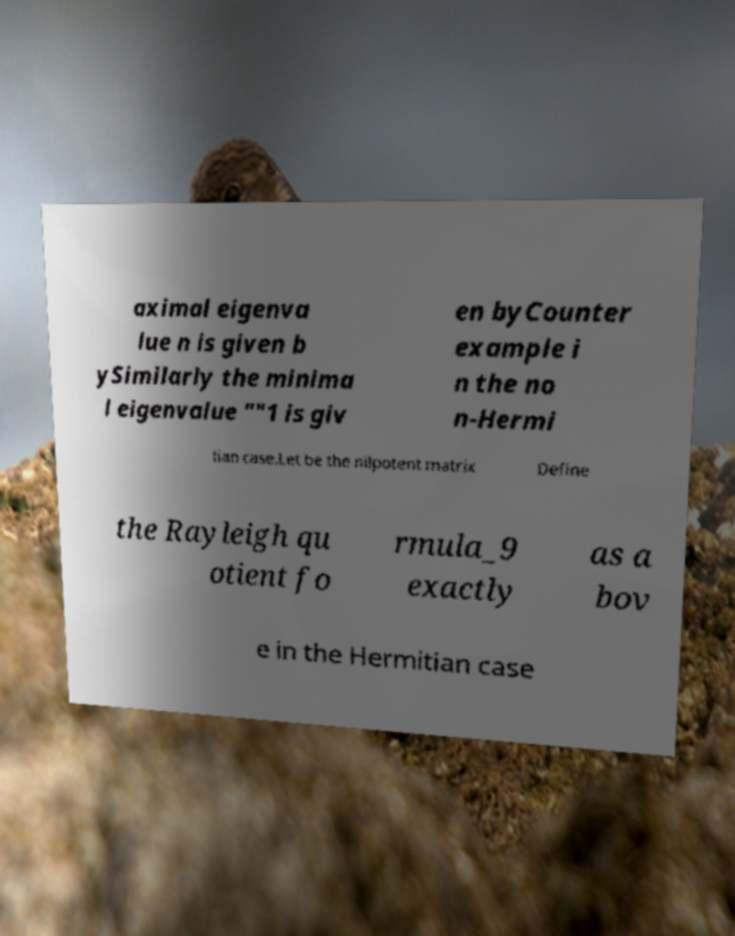I need the written content from this picture converted into text. Can you do that? aximal eigenva lue n is given b ySimilarly the minima l eigenvalue ""1 is giv en byCounter example i n the no n-Hermi tian case.Let be the nilpotent matrix Define the Rayleigh qu otient fo rmula_9 exactly as a bov e in the Hermitian case 